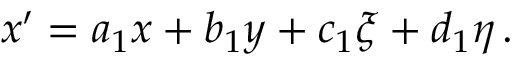<formula> <loc_0><loc_0><loc_500><loc_500>x ^ { \prime } = a _ { 1 } x + b _ { 1 } y + c _ { 1 } \xi + d _ { 1 } \eta \, .</formula> 